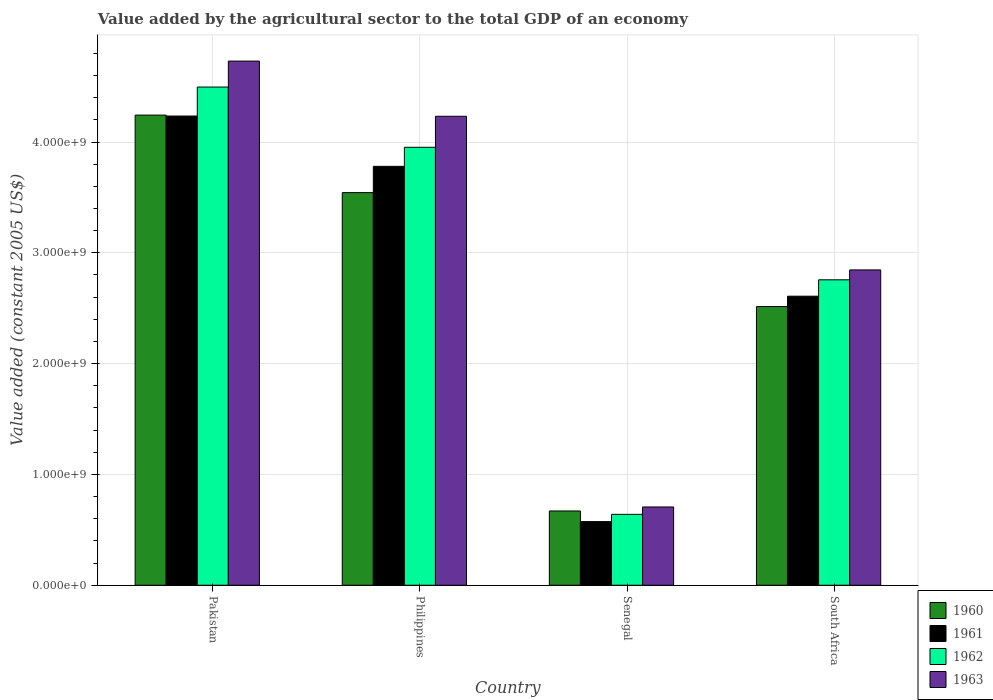How many different coloured bars are there?
Ensure brevity in your answer.  4. How many groups of bars are there?
Provide a short and direct response. 4. Are the number of bars per tick equal to the number of legend labels?
Your answer should be compact. Yes. Are the number of bars on each tick of the X-axis equal?
Your answer should be compact. Yes. What is the label of the 1st group of bars from the left?
Offer a very short reply. Pakistan. In how many cases, is the number of bars for a given country not equal to the number of legend labels?
Give a very brief answer. 0. What is the value added by the agricultural sector in 1963 in Pakistan?
Offer a terse response. 4.73e+09. Across all countries, what is the maximum value added by the agricultural sector in 1960?
Ensure brevity in your answer.  4.24e+09. Across all countries, what is the minimum value added by the agricultural sector in 1961?
Provide a succinct answer. 5.74e+08. In which country was the value added by the agricultural sector in 1961 minimum?
Make the answer very short. Senegal. What is the total value added by the agricultural sector in 1962 in the graph?
Keep it short and to the point. 1.18e+1. What is the difference between the value added by the agricultural sector in 1962 in Philippines and that in South Africa?
Your answer should be very brief. 1.20e+09. What is the difference between the value added by the agricultural sector in 1963 in Philippines and the value added by the agricultural sector in 1961 in Pakistan?
Make the answer very short. -2.10e+06. What is the average value added by the agricultural sector in 1960 per country?
Offer a terse response. 2.74e+09. What is the difference between the value added by the agricultural sector of/in 1960 and value added by the agricultural sector of/in 1961 in Pakistan?
Your answer should be very brief. 8.56e+06. What is the ratio of the value added by the agricultural sector in 1962 in Pakistan to that in Senegal?
Your answer should be very brief. 7.03. Is the value added by the agricultural sector in 1963 in Pakistan less than that in South Africa?
Give a very brief answer. No. Is the difference between the value added by the agricultural sector in 1960 in Pakistan and Philippines greater than the difference between the value added by the agricultural sector in 1961 in Pakistan and Philippines?
Offer a very short reply. Yes. What is the difference between the highest and the second highest value added by the agricultural sector in 1962?
Your response must be concise. 1.74e+09. What is the difference between the highest and the lowest value added by the agricultural sector in 1960?
Offer a terse response. 3.57e+09. Is it the case that in every country, the sum of the value added by the agricultural sector in 1963 and value added by the agricultural sector in 1961 is greater than the sum of value added by the agricultural sector in 1962 and value added by the agricultural sector in 1960?
Make the answer very short. No. Is it the case that in every country, the sum of the value added by the agricultural sector in 1962 and value added by the agricultural sector in 1960 is greater than the value added by the agricultural sector in 1961?
Provide a succinct answer. Yes. How many bars are there?
Make the answer very short. 16. How many countries are there in the graph?
Ensure brevity in your answer.  4. What is the difference between two consecutive major ticks on the Y-axis?
Provide a succinct answer. 1.00e+09. Does the graph contain any zero values?
Give a very brief answer. No. Does the graph contain grids?
Keep it short and to the point. Yes. How are the legend labels stacked?
Provide a short and direct response. Vertical. What is the title of the graph?
Offer a terse response. Value added by the agricultural sector to the total GDP of an economy. What is the label or title of the Y-axis?
Your answer should be very brief. Value added (constant 2005 US$). What is the Value added (constant 2005 US$) of 1960 in Pakistan?
Keep it short and to the point. 4.24e+09. What is the Value added (constant 2005 US$) in 1961 in Pakistan?
Make the answer very short. 4.23e+09. What is the Value added (constant 2005 US$) in 1962 in Pakistan?
Your answer should be compact. 4.50e+09. What is the Value added (constant 2005 US$) of 1963 in Pakistan?
Ensure brevity in your answer.  4.73e+09. What is the Value added (constant 2005 US$) in 1960 in Philippines?
Provide a short and direct response. 3.54e+09. What is the Value added (constant 2005 US$) of 1961 in Philippines?
Provide a short and direct response. 3.78e+09. What is the Value added (constant 2005 US$) in 1962 in Philippines?
Provide a succinct answer. 3.95e+09. What is the Value added (constant 2005 US$) of 1963 in Philippines?
Your response must be concise. 4.23e+09. What is the Value added (constant 2005 US$) in 1960 in Senegal?
Your response must be concise. 6.70e+08. What is the Value added (constant 2005 US$) of 1961 in Senegal?
Provide a succinct answer. 5.74e+08. What is the Value added (constant 2005 US$) of 1962 in Senegal?
Your answer should be compact. 6.40e+08. What is the Value added (constant 2005 US$) of 1963 in Senegal?
Provide a short and direct response. 7.06e+08. What is the Value added (constant 2005 US$) of 1960 in South Africa?
Provide a succinct answer. 2.52e+09. What is the Value added (constant 2005 US$) of 1961 in South Africa?
Your answer should be compact. 2.61e+09. What is the Value added (constant 2005 US$) of 1962 in South Africa?
Offer a terse response. 2.76e+09. What is the Value added (constant 2005 US$) of 1963 in South Africa?
Keep it short and to the point. 2.85e+09. Across all countries, what is the maximum Value added (constant 2005 US$) in 1960?
Give a very brief answer. 4.24e+09. Across all countries, what is the maximum Value added (constant 2005 US$) of 1961?
Offer a very short reply. 4.23e+09. Across all countries, what is the maximum Value added (constant 2005 US$) in 1962?
Offer a terse response. 4.50e+09. Across all countries, what is the maximum Value added (constant 2005 US$) of 1963?
Ensure brevity in your answer.  4.73e+09. Across all countries, what is the minimum Value added (constant 2005 US$) of 1960?
Ensure brevity in your answer.  6.70e+08. Across all countries, what is the minimum Value added (constant 2005 US$) in 1961?
Your answer should be compact. 5.74e+08. Across all countries, what is the minimum Value added (constant 2005 US$) in 1962?
Your answer should be very brief. 6.40e+08. Across all countries, what is the minimum Value added (constant 2005 US$) in 1963?
Your answer should be compact. 7.06e+08. What is the total Value added (constant 2005 US$) in 1960 in the graph?
Give a very brief answer. 1.10e+1. What is the total Value added (constant 2005 US$) in 1961 in the graph?
Make the answer very short. 1.12e+1. What is the total Value added (constant 2005 US$) of 1962 in the graph?
Provide a short and direct response. 1.18e+1. What is the total Value added (constant 2005 US$) of 1963 in the graph?
Make the answer very short. 1.25e+1. What is the difference between the Value added (constant 2005 US$) of 1960 in Pakistan and that in Philippines?
Your answer should be compact. 7.00e+08. What is the difference between the Value added (constant 2005 US$) in 1961 in Pakistan and that in Philippines?
Keep it short and to the point. 4.54e+08. What is the difference between the Value added (constant 2005 US$) in 1962 in Pakistan and that in Philippines?
Give a very brief answer. 5.44e+08. What is the difference between the Value added (constant 2005 US$) of 1963 in Pakistan and that in Philippines?
Give a very brief answer. 4.98e+08. What is the difference between the Value added (constant 2005 US$) in 1960 in Pakistan and that in Senegal?
Your answer should be very brief. 3.57e+09. What is the difference between the Value added (constant 2005 US$) of 1961 in Pakistan and that in Senegal?
Give a very brief answer. 3.66e+09. What is the difference between the Value added (constant 2005 US$) in 1962 in Pakistan and that in Senegal?
Offer a terse response. 3.86e+09. What is the difference between the Value added (constant 2005 US$) in 1963 in Pakistan and that in Senegal?
Give a very brief answer. 4.02e+09. What is the difference between the Value added (constant 2005 US$) of 1960 in Pakistan and that in South Africa?
Make the answer very short. 1.73e+09. What is the difference between the Value added (constant 2005 US$) of 1961 in Pakistan and that in South Africa?
Your answer should be very brief. 1.63e+09. What is the difference between the Value added (constant 2005 US$) of 1962 in Pakistan and that in South Africa?
Your answer should be very brief. 1.74e+09. What is the difference between the Value added (constant 2005 US$) in 1963 in Pakistan and that in South Africa?
Give a very brief answer. 1.88e+09. What is the difference between the Value added (constant 2005 US$) in 1960 in Philippines and that in Senegal?
Provide a succinct answer. 2.87e+09. What is the difference between the Value added (constant 2005 US$) in 1961 in Philippines and that in Senegal?
Ensure brevity in your answer.  3.21e+09. What is the difference between the Value added (constant 2005 US$) of 1962 in Philippines and that in Senegal?
Keep it short and to the point. 3.31e+09. What is the difference between the Value added (constant 2005 US$) in 1963 in Philippines and that in Senegal?
Make the answer very short. 3.53e+09. What is the difference between the Value added (constant 2005 US$) of 1960 in Philippines and that in South Africa?
Your answer should be compact. 1.03e+09. What is the difference between the Value added (constant 2005 US$) of 1961 in Philippines and that in South Africa?
Give a very brief answer. 1.17e+09. What is the difference between the Value added (constant 2005 US$) of 1962 in Philippines and that in South Africa?
Provide a succinct answer. 1.20e+09. What is the difference between the Value added (constant 2005 US$) in 1963 in Philippines and that in South Africa?
Provide a short and direct response. 1.39e+09. What is the difference between the Value added (constant 2005 US$) in 1960 in Senegal and that in South Africa?
Your answer should be compact. -1.84e+09. What is the difference between the Value added (constant 2005 US$) in 1961 in Senegal and that in South Africa?
Your answer should be compact. -2.03e+09. What is the difference between the Value added (constant 2005 US$) in 1962 in Senegal and that in South Africa?
Ensure brevity in your answer.  -2.12e+09. What is the difference between the Value added (constant 2005 US$) of 1963 in Senegal and that in South Africa?
Ensure brevity in your answer.  -2.14e+09. What is the difference between the Value added (constant 2005 US$) in 1960 in Pakistan and the Value added (constant 2005 US$) in 1961 in Philippines?
Your answer should be very brief. 4.62e+08. What is the difference between the Value added (constant 2005 US$) of 1960 in Pakistan and the Value added (constant 2005 US$) of 1962 in Philippines?
Provide a succinct answer. 2.90e+08. What is the difference between the Value added (constant 2005 US$) of 1960 in Pakistan and the Value added (constant 2005 US$) of 1963 in Philippines?
Offer a very short reply. 1.07e+07. What is the difference between the Value added (constant 2005 US$) of 1961 in Pakistan and the Value added (constant 2005 US$) of 1962 in Philippines?
Provide a succinct answer. 2.82e+08. What is the difference between the Value added (constant 2005 US$) in 1961 in Pakistan and the Value added (constant 2005 US$) in 1963 in Philippines?
Ensure brevity in your answer.  2.10e+06. What is the difference between the Value added (constant 2005 US$) of 1962 in Pakistan and the Value added (constant 2005 US$) of 1963 in Philippines?
Offer a very short reply. 2.64e+08. What is the difference between the Value added (constant 2005 US$) of 1960 in Pakistan and the Value added (constant 2005 US$) of 1961 in Senegal?
Provide a succinct answer. 3.67e+09. What is the difference between the Value added (constant 2005 US$) of 1960 in Pakistan and the Value added (constant 2005 US$) of 1962 in Senegal?
Provide a short and direct response. 3.60e+09. What is the difference between the Value added (constant 2005 US$) of 1960 in Pakistan and the Value added (constant 2005 US$) of 1963 in Senegal?
Give a very brief answer. 3.54e+09. What is the difference between the Value added (constant 2005 US$) in 1961 in Pakistan and the Value added (constant 2005 US$) in 1962 in Senegal?
Make the answer very short. 3.59e+09. What is the difference between the Value added (constant 2005 US$) in 1961 in Pakistan and the Value added (constant 2005 US$) in 1963 in Senegal?
Provide a short and direct response. 3.53e+09. What is the difference between the Value added (constant 2005 US$) in 1962 in Pakistan and the Value added (constant 2005 US$) in 1963 in Senegal?
Your response must be concise. 3.79e+09. What is the difference between the Value added (constant 2005 US$) in 1960 in Pakistan and the Value added (constant 2005 US$) in 1961 in South Africa?
Make the answer very short. 1.63e+09. What is the difference between the Value added (constant 2005 US$) of 1960 in Pakistan and the Value added (constant 2005 US$) of 1962 in South Africa?
Give a very brief answer. 1.49e+09. What is the difference between the Value added (constant 2005 US$) of 1960 in Pakistan and the Value added (constant 2005 US$) of 1963 in South Africa?
Keep it short and to the point. 1.40e+09. What is the difference between the Value added (constant 2005 US$) in 1961 in Pakistan and the Value added (constant 2005 US$) in 1962 in South Africa?
Offer a very short reply. 1.48e+09. What is the difference between the Value added (constant 2005 US$) in 1961 in Pakistan and the Value added (constant 2005 US$) in 1963 in South Africa?
Provide a short and direct response. 1.39e+09. What is the difference between the Value added (constant 2005 US$) of 1962 in Pakistan and the Value added (constant 2005 US$) of 1963 in South Africa?
Your response must be concise. 1.65e+09. What is the difference between the Value added (constant 2005 US$) of 1960 in Philippines and the Value added (constant 2005 US$) of 1961 in Senegal?
Provide a short and direct response. 2.97e+09. What is the difference between the Value added (constant 2005 US$) in 1960 in Philippines and the Value added (constant 2005 US$) in 1962 in Senegal?
Offer a terse response. 2.90e+09. What is the difference between the Value added (constant 2005 US$) in 1960 in Philippines and the Value added (constant 2005 US$) in 1963 in Senegal?
Your answer should be compact. 2.84e+09. What is the difference between the Value added (constant 2005 US$) in 1961 in Philippines and the Value added (constant 2005 US$) in 1962 in Senegal?
Your response must be concise. 3.14e+09. What is the difference between the Value added (constant 2005 US$) in 1961 in Philippines and the Value added (constant 2005 US$) in 1963 in Senegal?
Ensure brevity in your answer.  3.07e+09. What is the difference between the Value added (constant 2005 US$) of 1962 in Philippines and the Value added (constant 2005 US$) of 1963 in Senegal?
Keep it short and to the point. 3.25e+09. What is the difference between the Value added (constant 2005 US$) of 1960 in Philippines and the Value added (constant 2005 US$) of 1961 in South Africa?
Give a very brief answer. 9.35e+08. What is the difference between the Value added (constant 2005 US$) of 1960 in Philippines and the Value added (constant 2005 US$) of 1962 in South Africa?
Offer a terse response. 7.87e+08. What is the difference between the Value added (constant 2005 US$) in 1960 in Philippines and the Value added (constant 2005 US$) in 1963 in South Africa?
Provide a succinct answer. 6.98e+08. What is the difference between the Value added (constant 2005 US$) in 1961 in Philippines and the Value added (constant 2005 US$) in 1962 in South Africa?
Your response must be concise. 1.02e+09. What is the difference between the Value added (constant 2005 US$) of 1961 in Philippines and the Value added (constant 2005 US$) of 1963 in South Africa?
Your answer should be very brief. 9.35e+08. What is the difference between the Value added (constant 2005 US$) of 1962 in Philippines and the Value added (constant 2005 US$) of 1963 in South Africa?
Keep it short and to the point. 1.11e+09. What is the difference between the Value added (constant 2005 US$) of 1960 in Senegal and the Value added (constant 2005 US$) of 1961 in South Africa?
Keep it short and to the point. -1.94e+09. What is the difference between the Value added (constant 2005 US$) in 1960 in Senegal and the Value added (constant 2005 US$) in 1962 in South Africa?
Your response must be concise. -2.09e+09. What is the difference between the Value added (constant 2005 US$) in 1960 in Senegal and the Value added (constant 2005 US$) in 1963 in South Africa?
Ensure brevity in your answer.  -2.18e+09. What is the difference between the Value added (constant 2005 US$) in 1961 in Senegal and the Value added (constant 2005 US$) in 1962 in South Africa?
Your response must be concise. -2.18e+09. What is the difference between the Value added (constant 2005 US$) of 1961 in Senegal and the Value added (constant 2005 US$) of 1963 in South Africa?
Offer a terse response. -2.27e+09. What is the difference between the Value added (constant 2005 US$) of 1962 in Senegal and the Value added (constant 2005 US$) of 1963 in South Africa?
Keep it short and to the point. -2.21e+09. What is the average Value added (constant 2005 US$) of 1960 per country?
Your answer should be compact. 2.74e+09. What is the average Value added (constant 2005 US$) in 1961 per country?
Provide a succinct answer. 2.80e+09. What is the average Value added (constant 2005 US$) of 1962 per country?
Provide a short and direct response. 2.96e+09. What is the average Value added (constant 2005 US$) in 1963 per country?
Make the answer very short. 3.13e+09. What is the difference between the Value added (constant 2005 US$) in 1960 and Value added (constant 2005 US$) in 1961 in Pakistan?
Make the answer very short. 8.56e+06. What is the difference between the Value added (constant 2005 US$) of 1960 and Value added (constant 2005 US$) of 1962 in Pakistan?
Your answer should be very brief. -2.53e+08. What is the difference between the Value added (constant 2005 US$) in 1960 and Value added (constant 2005 US$) in 1963 in Pakistan?
Your answer should be compact. -4.87e+08. What is the difference between the Value added (constant 2005 US$) in 1961 and Value added (constant 2005 US$) in 1962 in Pakistan?
Keep it short and to the point. -2.62e+08. What is the difference between the Value added (constant 2005 US$) of 1961 and Value added (constant 2005 US$) of 1963 in Pakistan?
Offer a very short reply. -4.96e+08. What is the difference between the Value added (constant 2005 US$) in 1962 and Value added (constant 2005 US$) in 1963 in Pakistan?
Make the answer very short. -2.34e+08. What is the difference between the Value added (constant 2005 US$) of 1960 and Value added (constant 2005 US$) of 1961 in Philippines?
Your response must be concise. -2.37e+08. What is the difference between the Value added (constant 2005 US$) in 1960 and Value added (constant 2005 US$) in 1962 in Philippines?
Ensure brevity in your answer.  -4.09e+08. What is the difference between the Value added (constant 2005 US$) of 1960 and Value added (constant 2005 US$) of 1963 in Philippines?
Keep it short and to the point. -6.89e+08. What is the difference between the Value added (constant 2005 US$) of 1961 and Value added (constant 2005 US$) of 1962 in Philippines?
Provide a short and direct response. -1.72e+08. What is the difference between the Value added (constant 2005 US$) of 1961 and Value added (constant 2005 US$) of 1963 in Philippines?
Give a very brief answer. -4.52e+08. What is the difference between the Value added (constant 2005 US$) in 1962 and Value added (constant 2005 US$) in 1963 in Philippines?
Your response must be concise. -2.80e+08. What is the difference between the Value added (constant 2005 US$) in 1960 and Value added (constant 2005 US$) in 1961 in Senegal?
Provide a short and direct response. 9.60e+07. What is the difference between the Value added (constant 2005 US$) of 1960 and Value added (constant 2005 US$) of 1962 in Senegal?
Ensure brevity in your answer.  3.06e+07. What is the difference between the Value added (constant 2005 US$) in 1960 and Value added (constant 2005 US$) in 1963 in Senegal?
Ensure brevity in your answer.  -3.60e+07. What is the difference between the Value added (constant 2005 US$) of 1961 and Value added (constant 2005 US$) of 1962 in Senegal?
Your answer should be compact. -6.53e+07. What is the difference between the Value added (constant 2005 US$) in 1961 and Value added (constant 2005 US$) in 1963 in Senegal?
Your response must be concise. -1.32e+08. What is the difference between the Value added (constant 2005 US$) of 1962 and Value added (constant 2005 US$) of 1963 in Senegal?
Your answer should be very brief. -6.67e+07. What is the difference between the Value added (constant 2005 US$) of 1960 and Value added (constant 2005 US$) of 1961 in South Africa?
Make the answer very short. -9.34e+07. What is the difference between the Value added (constant 2005 US$) of 1960 and Value added (constant 2005 US$) of 1962 in South Africa?
Keep it short and to the point. -2.41e+08. What is the difference between the Value added (constant 2005 US$) in 1960 and Value added (constant 2005 US$) in 1963 in South Africa?
Provide a succinct answer. -3.31e+08. What is the difference between the Value added (constant 2005 US$) in 1961 and Value added (constant 2005 US$) in 1962 in South Africa?
Provide a succinct answer. -1.48e+08. What is the difference between the Value added (constant 2005 US$) of 1961 and Value added (constant 2005 US$) of 1963 in South Africa?
Give a very brief answer. -2.37e+08. What is the difference between the Value added (constant 2005 US$) of 1962 and Value added (constant 2005 US$) of 1963 in South Africa?
Provide a succinct answer. -8.93e+07. What is the ratio of the Value added (constant 2005 US$) of 1960 in Pakistan to that in Philippines?
Make the answer very short. 1.2. What is the ratio of the Value added (constant 2005 US$) in 1961 in Pakistan to that in Philippines?
Your answer should be very brief. 1.12. What is the ratio of the Value added (constant 2005 US$) in 1962 in Pakistan to that in Philippines?
Ensure brevity in your answer.  1.14. What is the ratio of the Value added (constant 2005 US$) in 1963 in Pakistan to that in Philippines?
Ensure brevity in your answer.  1.12. What is the ratio of the Value added (constant 2005 US$) of 1960 in Pakistan to that in Senegal?
Your answer should be very brief. 6.33. What is the ratio of the Value added (constant 2005 US$) in 1961 in Pakistan to that in Senegal?
Keep it short and to the point. 7.37. What is the ratio of the Value added (constant 2005 US$) of 1962 in Pakistan to that in Senegal?
Offer a very short reply. 7.03. What is the ratio of the Value added (constant 2005 US$) in 1963 in Pakistan to that in Senegal?
Provide a short and direct response. 6.7. What is the ratio of the Value added (constant 2005 US$) of 1960 in Pakistan to that in South Africa?
Offer a very short reply. 1.69. What is the ratio of the Value added (constant 2005 US$) of 1961 in Pakistan to that in South Africa?
Your response must be concise. 1.62. What is the ratio of the Value added (constant 2005 US$) in 1962 in Pakistan to that in South Africa?
Your answer should be compact. 1.63. What is the ratio of the Value added (constant 2005 US$) in 1963 in Pakistan to that in South Africa?
Provide a succinct answer. 1.66. What is the ratio of the Value added (constant 2005 US$) of 1960 in Philippines to that in Senegal?
Provide a succinct answer. 5.29. What is the ratio of the Value added (constant 2005 US$) of 1961 in Philippines to that in Senegal?
Offer a terse response. 6.58. What is the ratio of the Value added (constant 2005 US$) of 1962 in Philippines to that in Senegal?
Your answer should be very brief. 6.18. What is the ratio of the Value added (constant 2005 US$) of 1963 in Philippines to that in Senegal?
Provide a succinct answer. 5.99. What is the ratio of the Value added (constant 2005 US$) of 1960 in Philippines to that in South Africa?
Your answer should be very brief. 1.41. What is the ratio of the Value added (constant 2005 US$) of 1961 in Philippines to that in South Africa?
Provide a succinct answer. 1.45. What is the ratio of the Value added (constant 2005 US$) of 1962 in Philippines to that in South Africa?
Your answer should be very brief. 1.43. What is the ratio of the Value added (constant 2005 US$) of 1963 in Philippines to that in South Africa?
Provide a succinct answer. 1.49. What is the ratio of the Value added (constant 2005 US$) of 1960 in Senegal to that in South Africa?
Your answer should be compact. 0.27. What is the ratio of the Value added (constant 2005 US$) of 1961 in Senegal to that in South Africa?
Your response must be concise. 0.22. What is the ratio of the Value added (constant 2005 US$) of 1962 in Senegal to that in South Africa?
Your answer should be very brief. 0.23. What is the ratio of the Value added (constant 2005 US$) in 1963 in Senegal to that in South Africa?
Keep it short and to the point. 0.25. What is the difference between the highest and the second highest Value added (constant 2005 US$) of 1960?
Provide a succinct answer. 7.00e+08. What is the difference between the highest and the second highest Value added (constant 2005 US$) in 1961?
Provide a succinct answer. 4.54e+08. What is the difference between the highest and the second highest Value added (constant 2005 US$) of 1962?
Offer a terse response. 5.44e+08. What is the difference between the highest and the second highest Value added (constant 2005 US$) of 1963?
Offer a very short reply. 4.98e+08. What is the difference between the highest and the lowest Value added (constant 2005 US$) in 1960?
Provide a succinct answer. 3.57e+09. What is the difference between the highest and the lowest Value added (constant 2005 US$) in 1961?
Give a very brief answer. 3.66e+09. What is the difference between the highest and the lowest Value added (constant 2005 US$) in 1962?
Ensure brevity in your answer.  3.86e+09. What is the difference between the highest and the lowest Value added (constant 2005 US$) in 1963?
Offer a very short reply. 4.02e+09. 